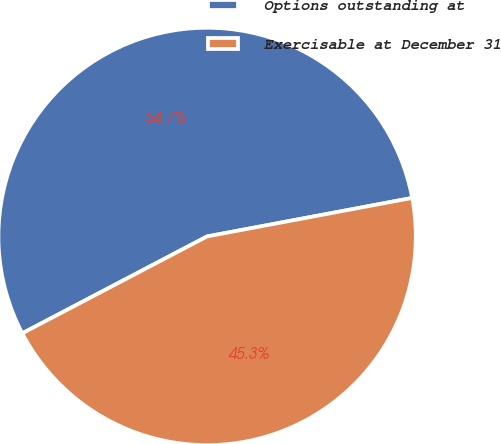Convert chart to OTSL. <chart><loc_0><loc_0><loc_500><loc_500><pie_chart><fcel>Options outstanding at<fcel>Exercisable at December 31<nl><fcel>54.73%<fcel>45.27%<nl></chart> 